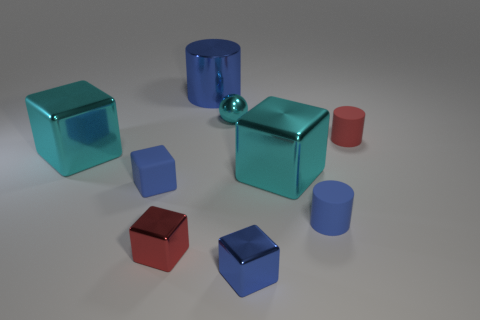Subtract all blue blocks. How many blocks are left? 3 Add 1 blue cylinders. How many objects exist? 10 Subtract all red cylinders. How many cyan blocks are left? 2 Subtract all red cylinders. How many cylinders are left? 2 Subtract all cylinders. How many objects are left? 6 Subtract 2 cubes. How many cubes are left? 3 Add 2 brown shiny objects. How many brown shiny objects exist? 2 Subtract 0 brown spheres. How many objects are left? 9 Subtract all green blocks. Subtract all gray balls. How many blocks are left? 5 Subtract all cyan metal cubes. Subtract all small red rubber objects. How many objects are left? 6 